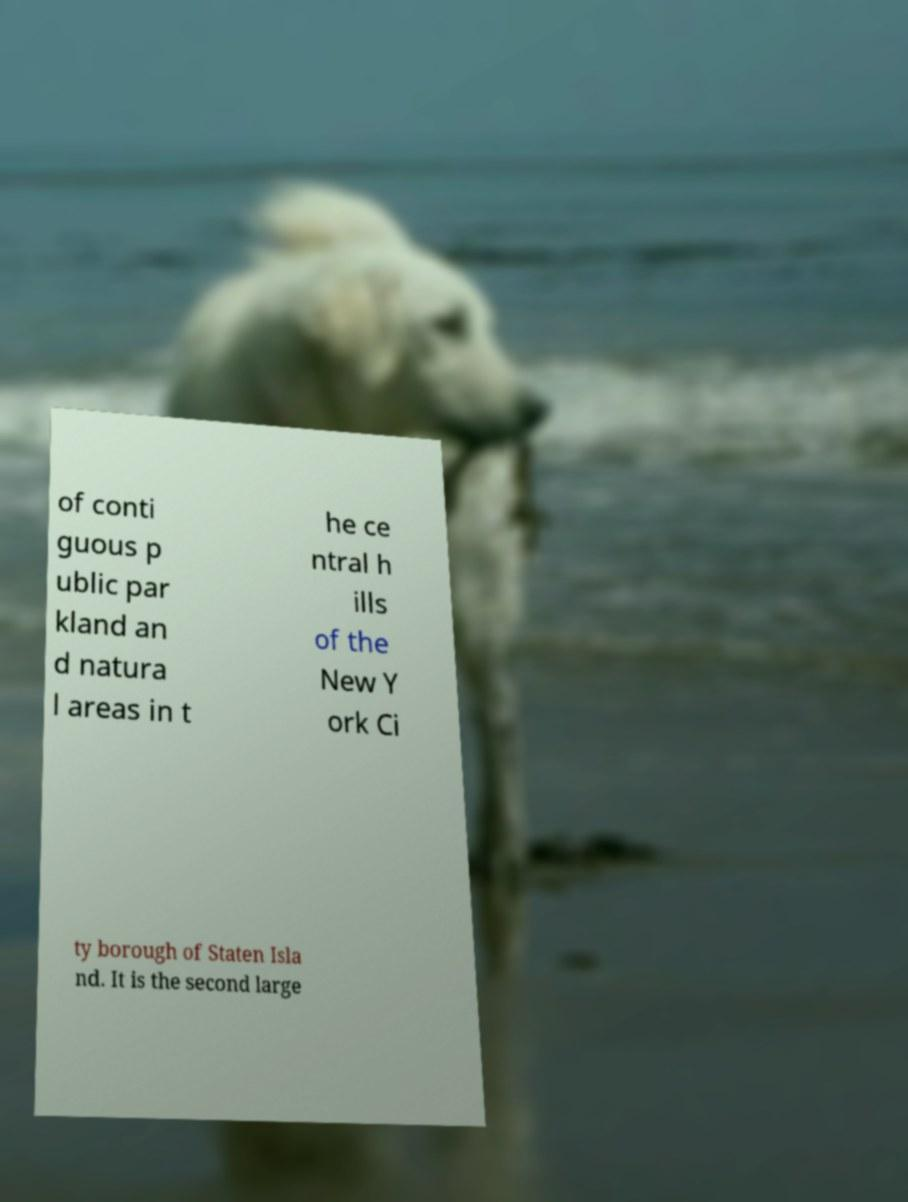I need the written content from this picture converted into text. Can you do that? of conti guous p ublic par kland an d natura l areas in t he ce ntral h ills of the New Y ork Ci ty borough of Staten Isla nd. It is the second large 